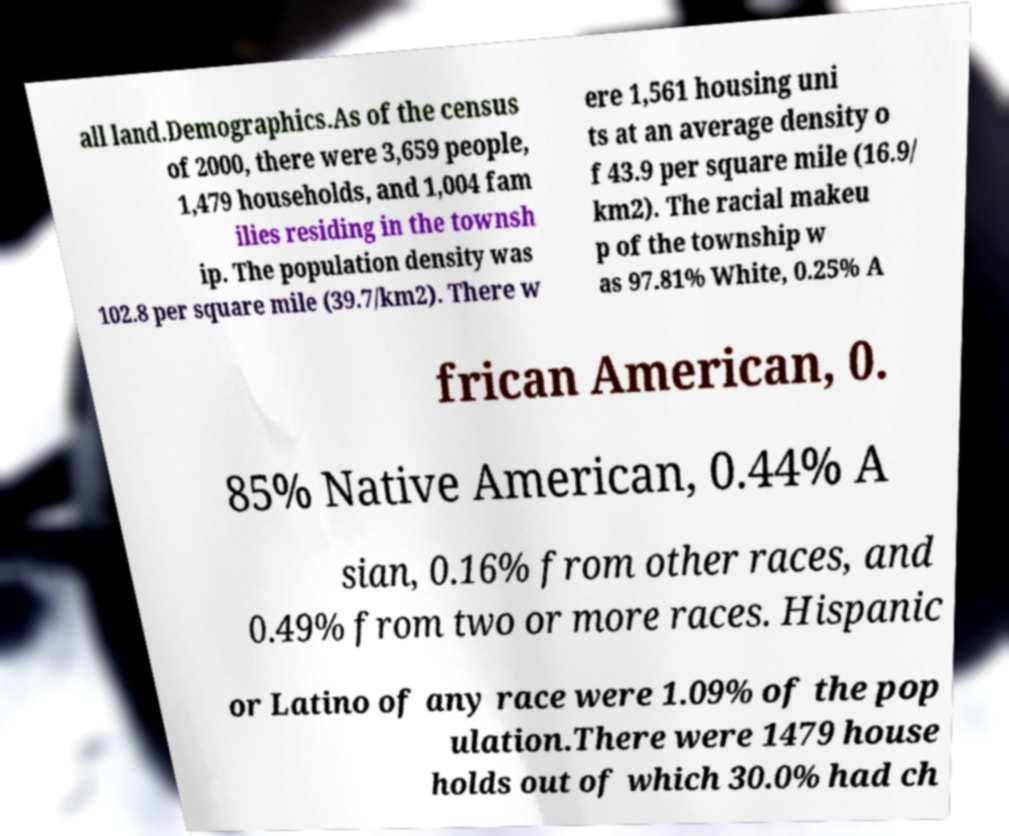I need the written content from this picture converted into text. Can you do that? all land.Demographics.As of the census of 2000, there were 3,659 people, 1,479 households, and 1,004 fam ilies residing in the townsh ip. The population density was 102.8 per square mile (39.7/km2). There w ere 1,561 housing uni ts at an average density o f 43.9 per square mile (16.9/ km2). The racial makeu p of the township w as 97.81% White, 0.25% A frican American, 0. 85% Native American, 0.44% A sian, 0.16% from other races, and 0.49% from two or more races. Hispanic or Latino of any race were 1.09% of the pop ulation.There were 1479 house holds out of which 30.0% had ch 